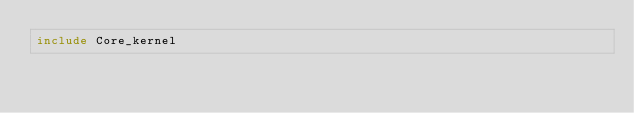Convert code to text. <code><loc_0><loc_0><loc_500><loc_500><_OCaml_>include Core_kernel
</code> 